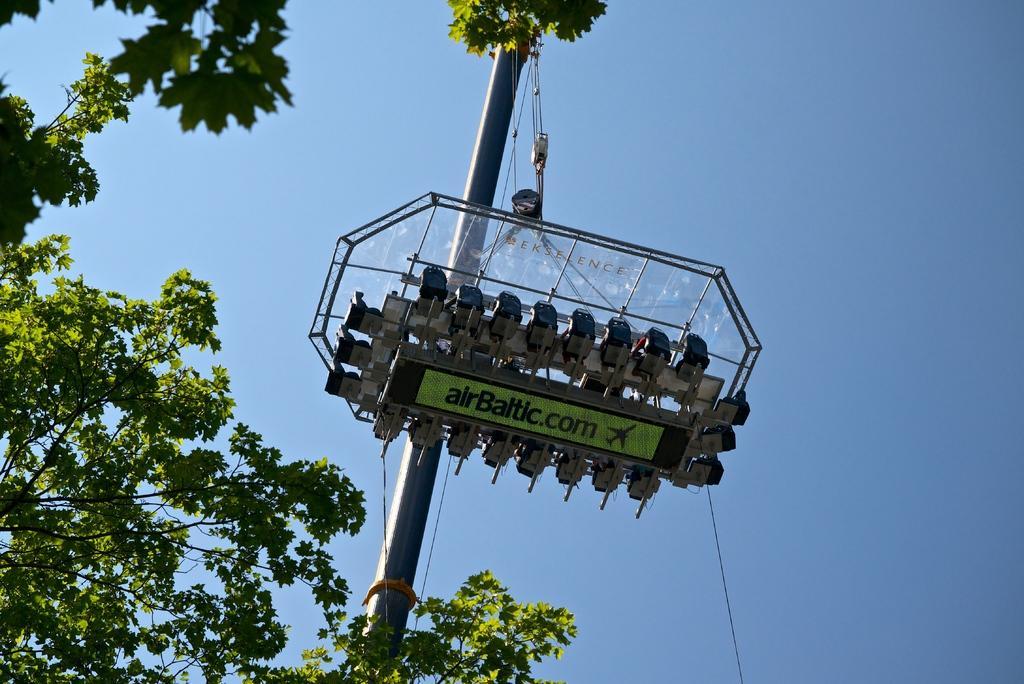Can you describe this image briefly? In this image in the front there are trees and there is a pole and on the pole there is an object with some text written on it. 